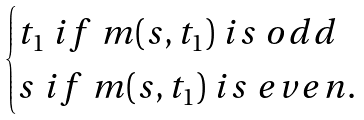Convert formula to latex. <formula><loc_0><loc_0><loc_500><loc_500>\begin{cases} t _ { 1 } \ i f \ m ( s , t _ { 1 } ) \ i s \ o d d \\ s \ i f \ m ( s , t _ { 1 } ) \ i s \ e v e n . \end{cases}</formula> 